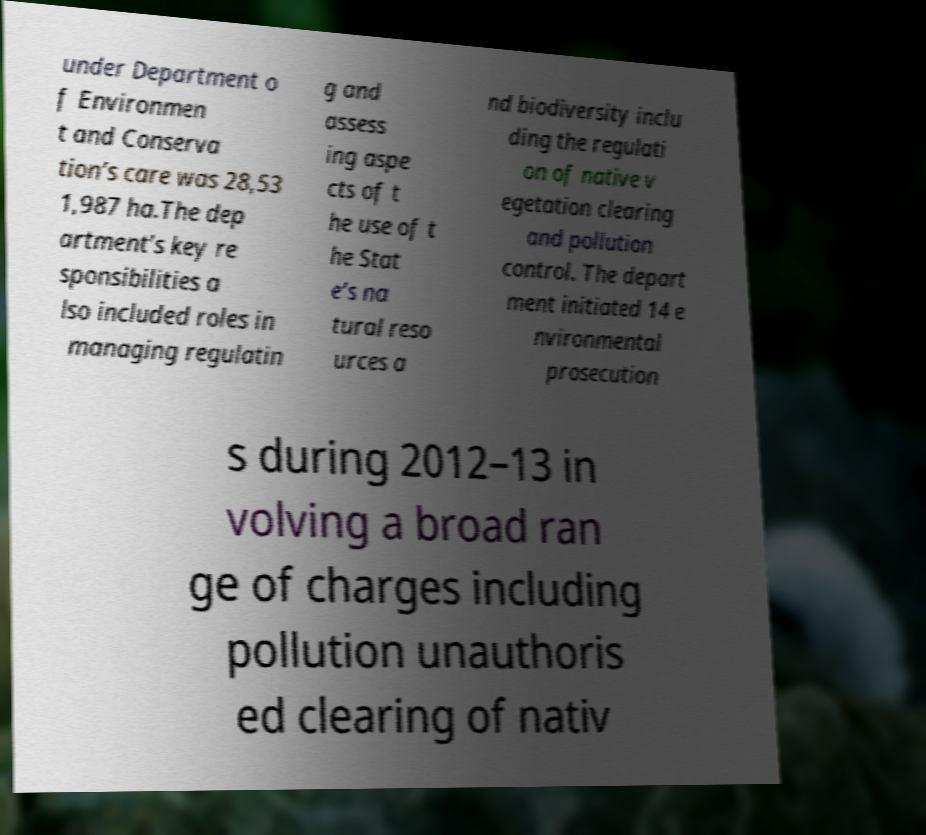Please identify and transcribe the text found in this image. under Department o f Environmen t and Conserva tion’s care was 28,53 1,987 ha.The dep artment’s key re sponsibilities a lso included roles in managing regulatin g and assess ing aspe cts of t he use of t he Stat e’s na tural reso urces a nd biodiversity inclu ding the regulati on of native v egetation clearing and pollution control. The depart ment initiated 14 e nvironmental prosecution s during 2012–13 in volving a broad ran ge of charges including pollution unauthoris ed clearing of nativ 